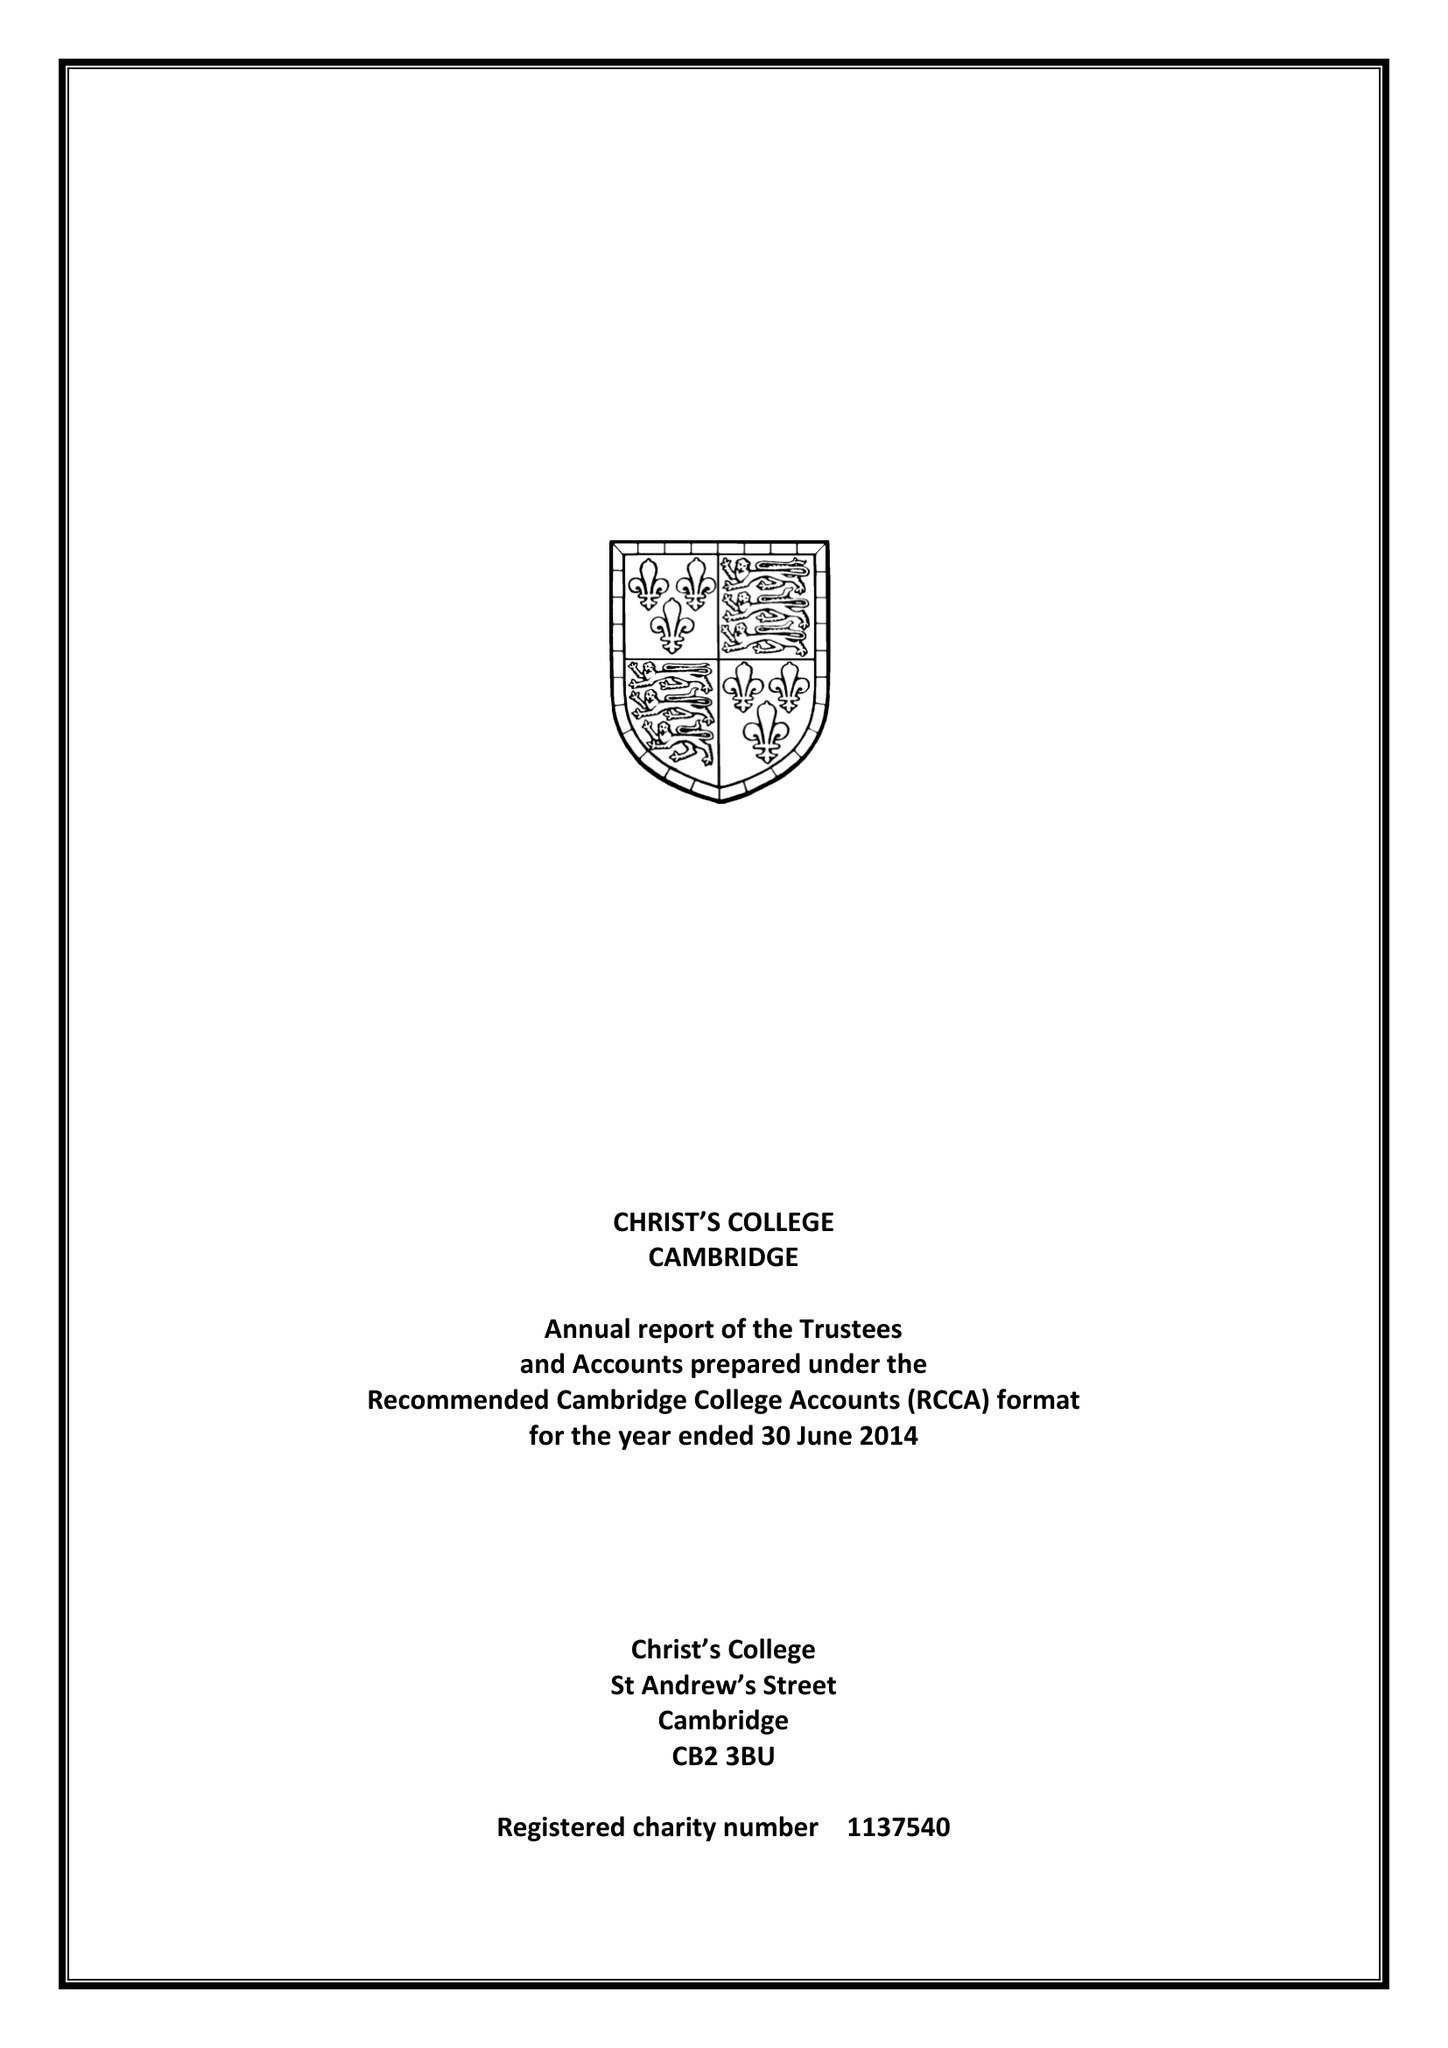What is the value for the address__postcode?
Answer the question using a single word or phrase. CB2 3BU 